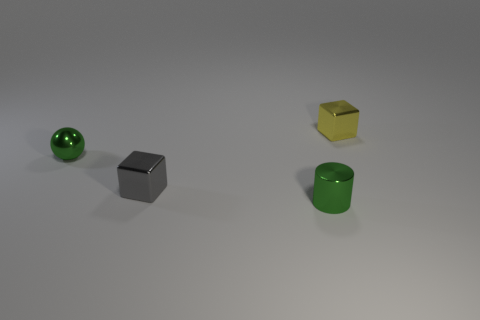Is there a object that has the same color as the sphere?
Your response must be concise. Yes. There is a green cylinder that is made of the same material as the yellow thing; what size is it?
Your response must be concise. Small. Are there more green balls in front of the shiny cylinder than metal spheres that are behind the yellow metallic block?
Give a very brief answer. No. How many other objects are there of the same material as the gray block?
Your answer should be compact. 3. Is the material of the green thing that is in front of the tiny gray cube the same as the small yellow object?
Your answer should be very brief. Yes. The small gray object has what shape?
Give a very brief answer. Cube. Are there more gray objects on the right side of the tiny green metal cylinder than tiny gray cubes?
Provide a succinct answer. No. Is there anything else that has the same shape as the small yellow shiny thing?
Your response must be concise. Yes. There is another small object that is the same shape as the yellow metallic thing; what is its color?
Make the answer very short. Gray. What is the shape of the tiny green object behind the small green cylinder?
Provide a short and direct response. Sphere. 